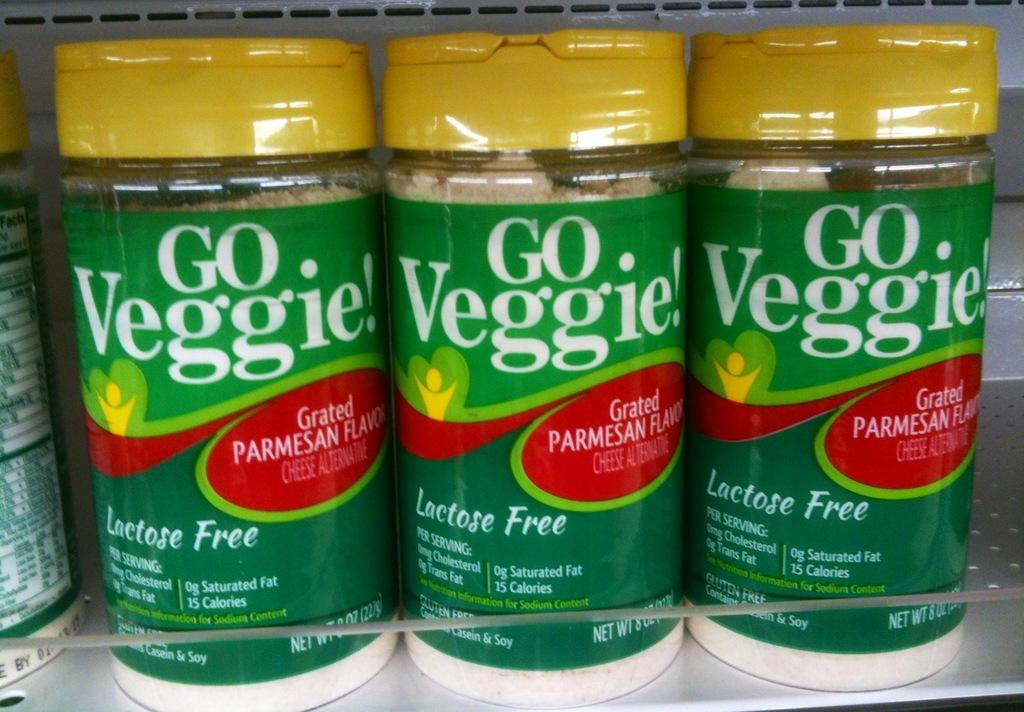<image>
Summarize the visual content of the image. Three containers of Go Veggie! grated cheese on a shelf. 